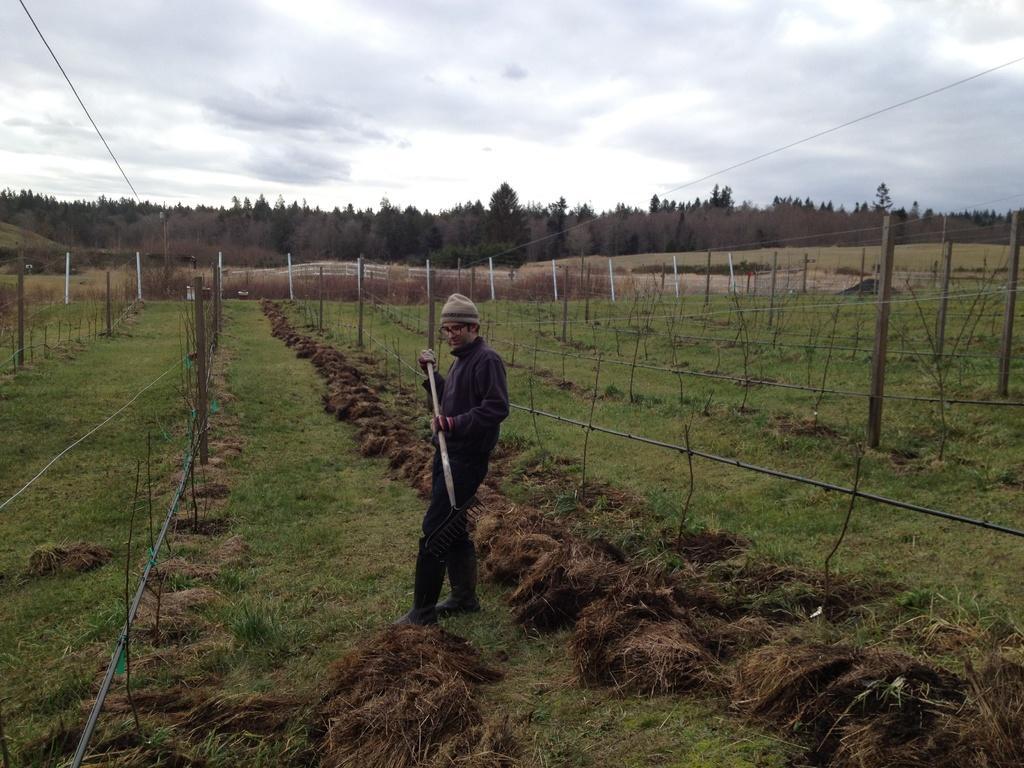How would you summarize this image in a sentence or two? In this picture, we see the man is standing. He is holding the crowbar in his hands and he is even wearing the spectacles and a cap. In front of him, we see the fence. Behind him, we see the fence. There are trees in the background. At the top, we see the sky and the wires. 